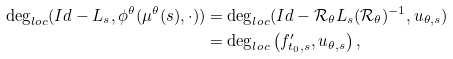Convert formula to latex. <formula><loc_0><loc_0><loc_500><loc_500>\deg _ { l o c } ( I d - L _ { s } , \phi ^ { \theta } ( \mu ^ { \theta } ( s ) , \cdot ) ) & = \deg _ { l o c } ( I d - { \mathcal { R } } _ { \theta } L _ { s } ( { \mathcal { R } } _ { \theta } ) ^ { - 1 } , u _ { \theta , s } ) \\ & = \deg _ { l o c } \left ( f _ { t _ { 0 } , s } ^ { \prime } , u _ { \theta , s } \right ) ,</formula> 